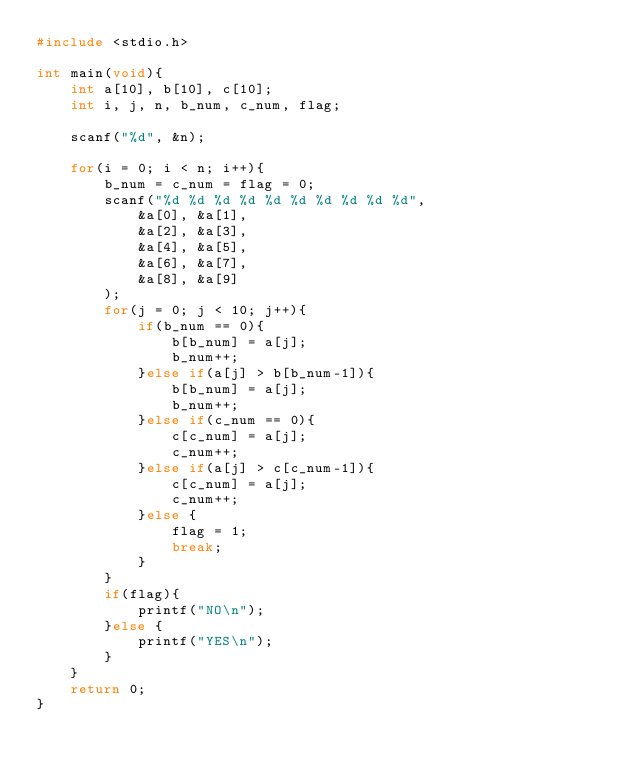<code> <loc_0><loc_0><loc_500><loc_500><_C_>#include <stdio.h>

int main(void){
	int a[10], b[10], c[10];
	int i, j, n, b_num, c_num, flag;
	
	scanf("%d", &n);
	
	for(i = 0; i < n; i++){
		b_num = c_num = flag = 0;
		scanf("%d %d %d %d %d %d %d %d %d %d", 
			&a[0], &a[1],
			&a[2], &a[3], 
			&a[4], &a[5], 
			&a[6], &a[7], 
			&a[8], &a[9]
		);
		for(j = 0; j < 10; j++){
			if(b_num == 0){
				b[b_num] = a[j];
				b_num++;
			}else if(a[j] > b[b_num-1]){
				b[b_num] = a[j];
				b_num++;
			}else if(c_num == 0){
				c[c_num] = a[j];
				c_num++;
			}else if(a[j] > c[c_num-1]){
				c[c_num] = a[j];
				c_num++;
			}else {
				flag = 1;
				break;
			}
		}
		if(flag){
			printf("NO\n");
		}else {
			printf("YES\n");
		}
	}
	return 0;
}</code> 